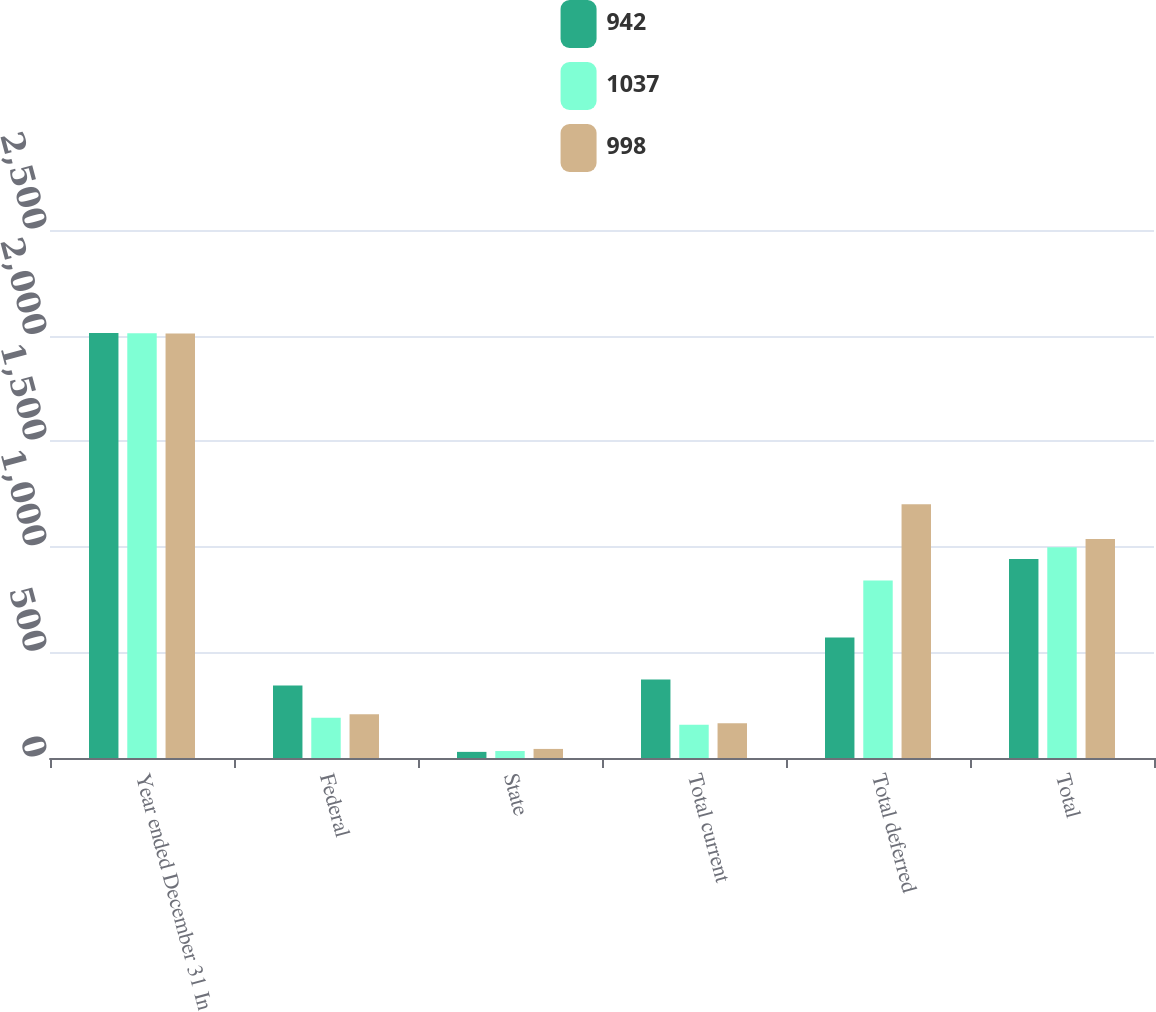Convert chart to OTSL. <chart><loc_0><loc_0><loc_500><loc_500><stacked_bar_chart><ecel><fcel>Year ended December 31 In<fcel>Federal<fcel>State<fcel>Total current<fcel>Total deferred<fcel>Total<nl><fcel>942<fcel>2012<fcel>343<fcel>29<fcel>372<fcel>570<fcel>942<nl><fcel>1037<fcel>2011<fcel>191<fcel>33<fcel>158<fcel>840<fcel>998<nl><fcel>998<fcel>2010<fcel>207<fcel>43<fcel>164<fcel>1201<fcel>1037<nl></chart> 